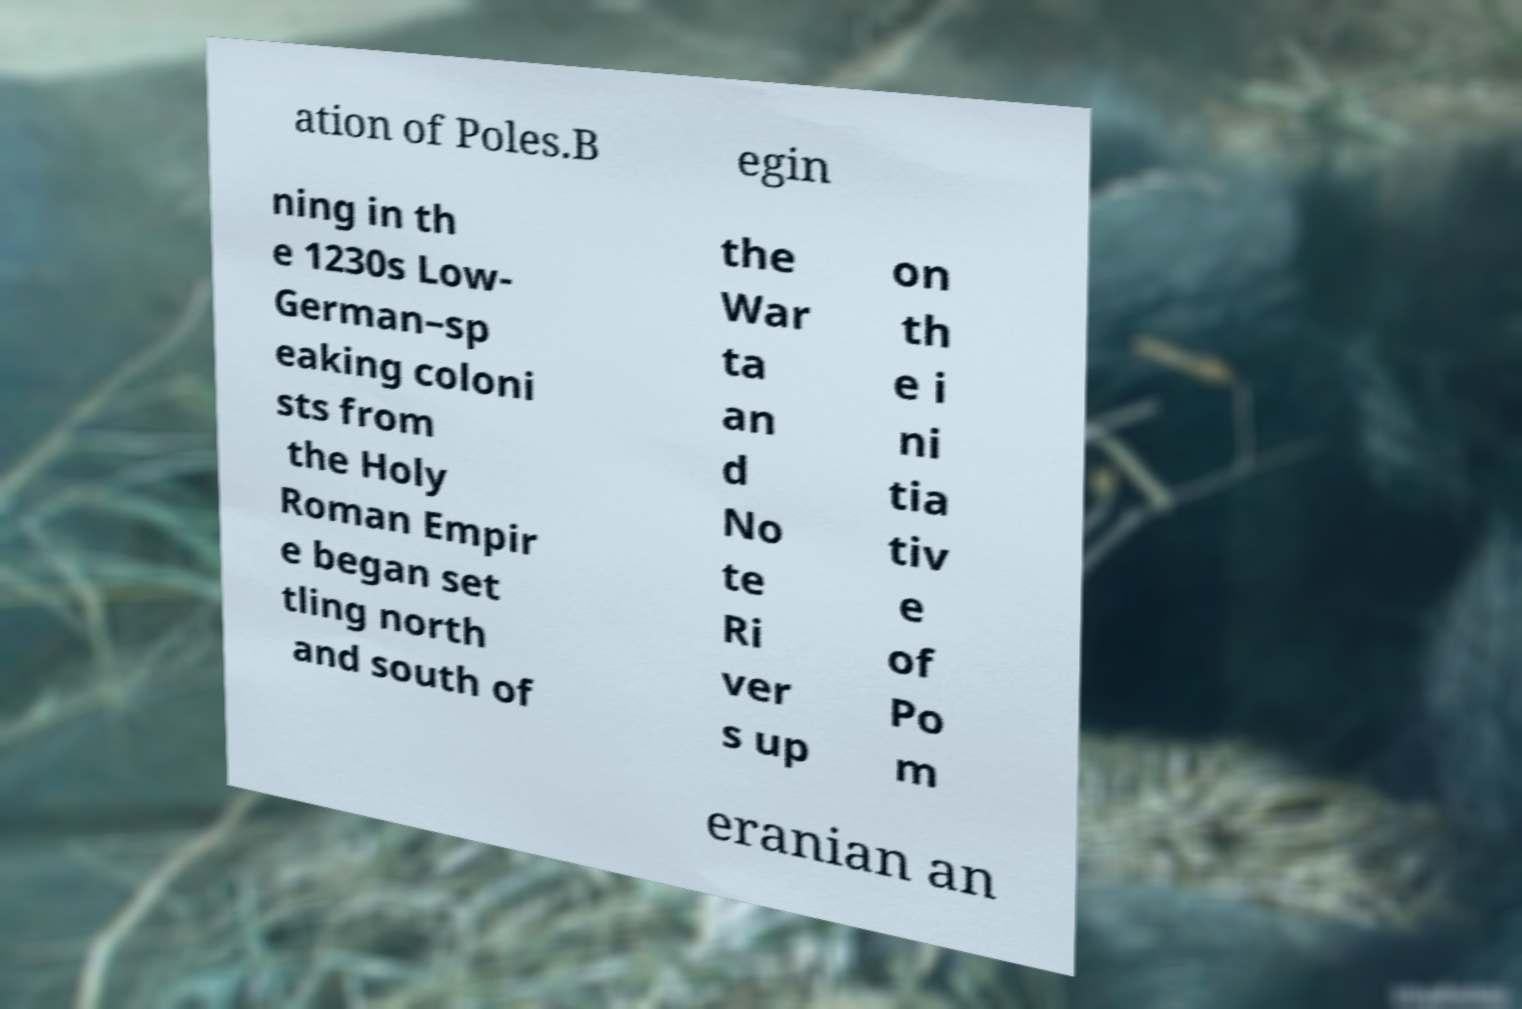I need the written content from this picture converted into text. Can you do that? ation of Poles.B egin ning in th e 1230s Low- German–sp eaking coloni sts from the Holy Roman Empir e began set tling north and south of the War ta an d No te Ri ver s up on th e i ni tia tiv e of Po m eranian an 